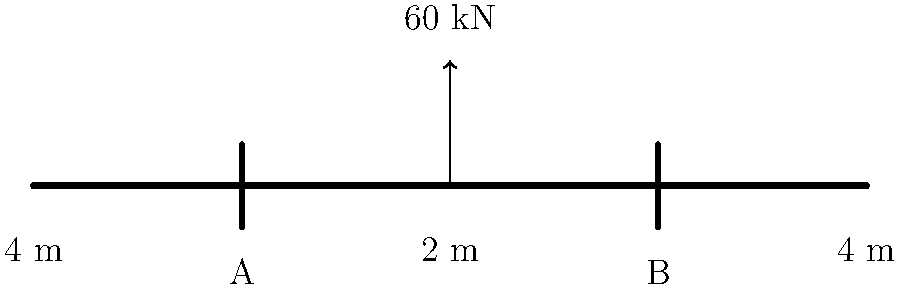As a former economic crime investigator, you're consulting on a case involving potential fraud in bridge construction. A simply supported bridge has a span of 10 meters with supports at points A and B, 4 meters from each end. A concentrated load of 60 kN is applied at the center of the bridge. Calculate the reaction forces at supports A and B. To solve this problem, we'll use the principles of statics and moment equilibrium:

1) First, let's establish the equilibrium equations:
   
   Sum of vertical forces: $R_A + R_B = 60$ kN
   
   Sum of moments about point A: $R_B \cdot 8 \text{ m} - 60 \text{ kN} \cdot 5 \text{ m} = 0$

2) From the moment equation:
   
   $R_B \cdot 8 \text{ m} = 60 \text{ kN} \cdot 5 \text{ m}$
   $R_B = \frac{60 \text{ kN} \cdot 5 \text{ m}}{8 \text{ m}} = 37.5 \text{ kN}$

3) Substituting this into the force equilibrium equation:
   
   $R_A + 37.5 \text{ kN} = 60 \text{ kN}$
   $R_A = 22.5 \text{ kN}$

4) Verify:
   $22.5 \text{ kN} + 37.5 \text{ kN} = 60 \text{ kN}$ (Checks out)

Therefore, the reaction force at support A is 22.5 kN and at support B is 37.5 kN.
Answer: $R_A = 22.5 \text{ kN}$, $R_B = 37.5 \text{ kN}$ 